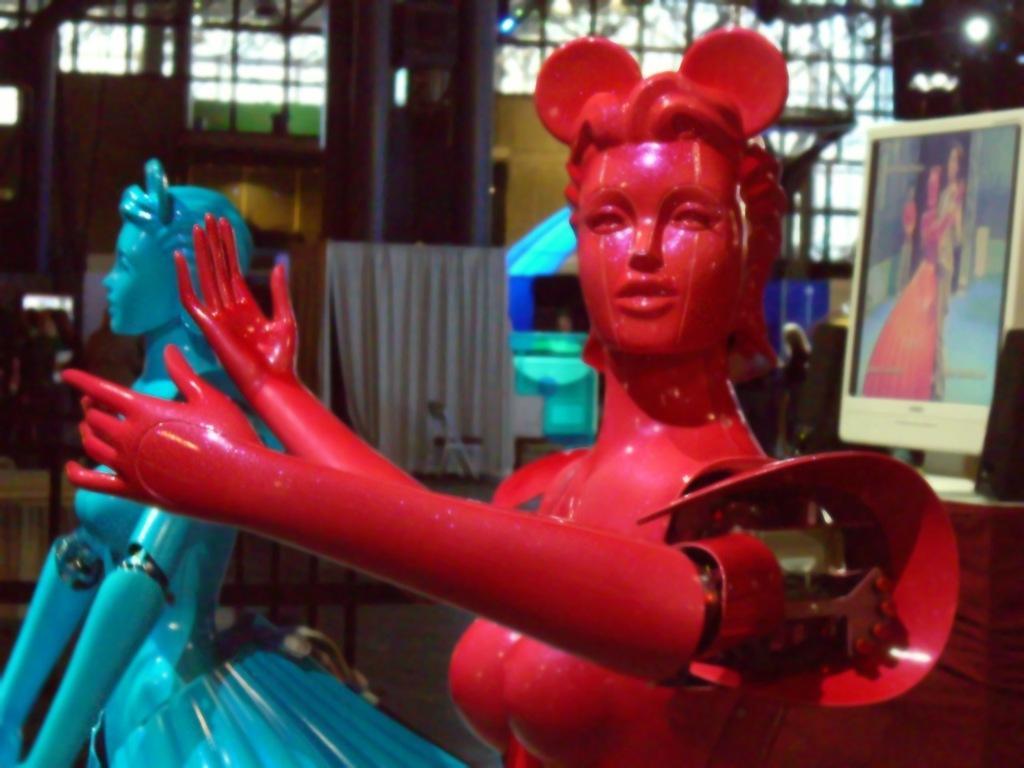In one or two sentences, can you explain what this image depicts? In this image I can see a red and a blue colour thing. In the background I can see a monitor, few speakers, a light and over there I can see a white colour thing. 